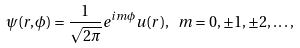<formula> <loc_0><loc_0><loc_500><loc_500>\psi ( r , \phi ) = \frac { 1 } { \sqrt { 2 \pi } } e ^ { i m \phi } u ( r ) , \text { } m = 0 , \pm 1 , \pm 2 , \dots ,</formula> 